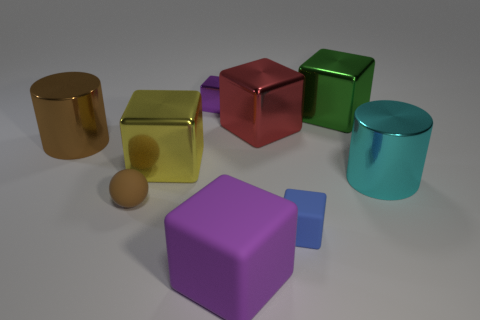The yellow metallic thing that is in front of the tiny purple shiny block has what shape?
Your answer should be very brief. Cube. Do the cyan thing and the big green object have the same material?
Make the answer very short. Yes. There is a large object in front of the cylinder in front of the large cylinder that is to the left of the big purple matte block; what shape is it?
Ensure brevity in your answer.  Cube. Is the number of large metal cylinders behind the large matte thing less than the number of small purple metal objects that are behind the purple metal object?
Offer a very short reply. No. The large object that is in front of the cyan shiny cylinder that is behind the brown rubber sphere is what shape?
Give a very brief answer. Cube. Is there anything else that is the same color as the large rubber cube?
Give a very brief answer. Yes. Is the color of the tiny rubber block the same as the matte ball?
Offer a terse response. No. What number of cyan things are either tiny spheres or tiny rubber blocks?
Your answer should be compact. 0. Are there fewer brown things in front of the big brown cylinder than purple blocks?
Keep it short and to the point. Yes. What number of purple blocks are behind the rubber block that is on the right side of the big purple rubber cube?
Give a very brief answer. 1. 